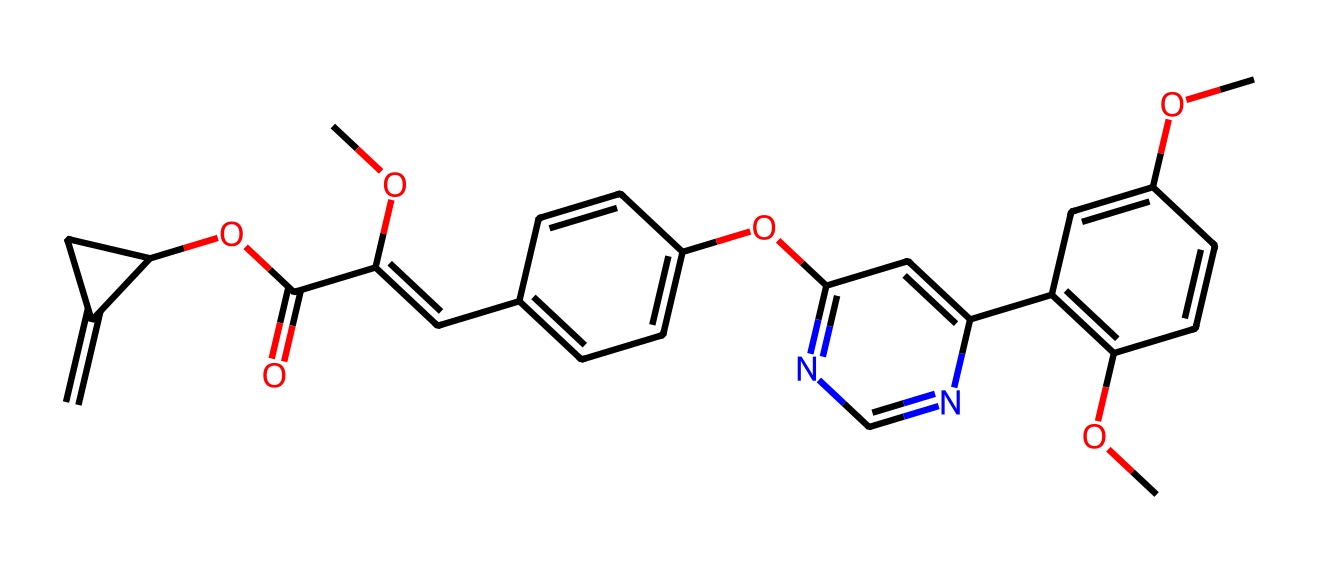What is the molecular formula of azoxystrobin? The molecular formula can be derived from the SMILES notation by counting each type of atom present. In this case, carbon (C), hydrogen (H), nitrogen (N), and oxygen (O) are present. Counting gives: C = 18, H = 18, N = 4, O = 5, leading to C18H18N4O5.
Answer: C18H18N4O5 How many rings are present in the structure? By visually inspecting the chemical structure implied by the SMILES notation, there are three distinct ring systems identified, which corresponds to three rings in the molecular structure.
Answer: 3 What functional groups are present in azoxystrobin? Identifying functional groups involves looking for specific patterns in the structure. In this case, there are methoxy (-OCH3) groups, an amine (due to the nitrogen), and ester groups, indicating the presence of these functional groups.
Answer: methoxy, amine, ester Which type of nitrogen atom is present in this chemical? There are both aromatic and non-aromatic nitrogen atoms present. The presence of the nitrogen atoms in the rings contributes to the aromatic nature, particularly in the context of the history and utility of this fungicide.
Answer: aromatic, non-aromatic Is azoxystrobin considered a systemic fungicide? A systemic fungicide is one that is absorbed and translocated throughout the plant, affecting its internal tissues. The molecular structure of azoxystrobin indicates that it is designed to be absorbed effectively, making it systemic.
Answer: Yes Which portion of the chemical's structure indicates its fungicidal properties? The entire structure, particularly the heterocyclic rings and the presence of nitrogen atoms, suggest that azoxystrobin can inhibit fungal respiration, leading to its action as a fungicide. This is derived from how these structures interact with biological processes in fungi.
Answer: heterocyclic rings, nitrogen atoms 